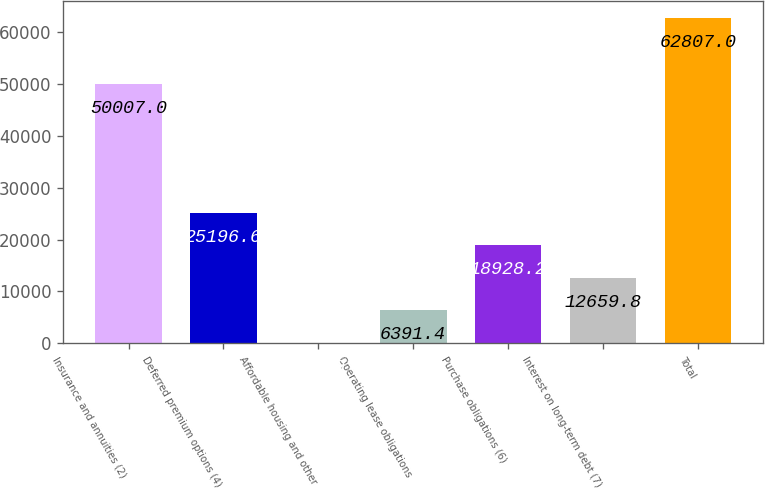<chart> <loc_0><loc_0><loc_500><loc_500><bar_chart><fcel>Insurance and annuities (2)<fcel>Deferred premium options (4)<fcel>Affordable housing and other<fcel>Operating lease obligations<fcel>Purchase obligations (6)<fcel>Interest on long-term debt (7)<fcel>Total<nl><fcel>50007<fcel>25196.6<fcel>123<fcel>6391.4<fcel>18928.2<fcel>12659.8<fcel>62807<nl></chart> 